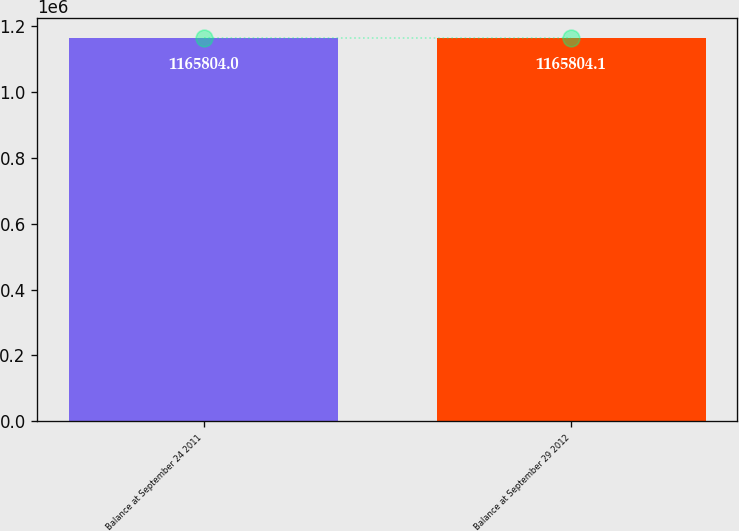<chart> <loc_0><loc_0><loc_500><loc_500><bar_chart><fcel>Balance at September 24 2011<fcel>Balance at September 29 2012<nl><fcel>1.1658e+06<fcel>1.1658e+06<nl></chart> 